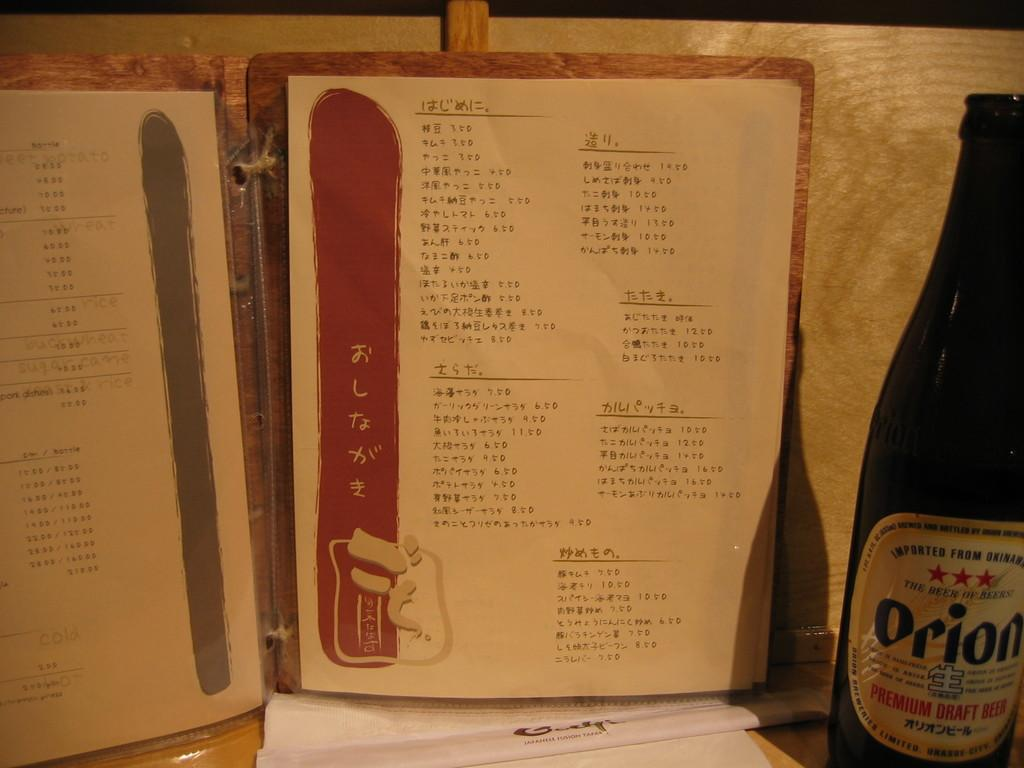<image>
Provide a brief description of the given image. a bottle of orion next to a menu 